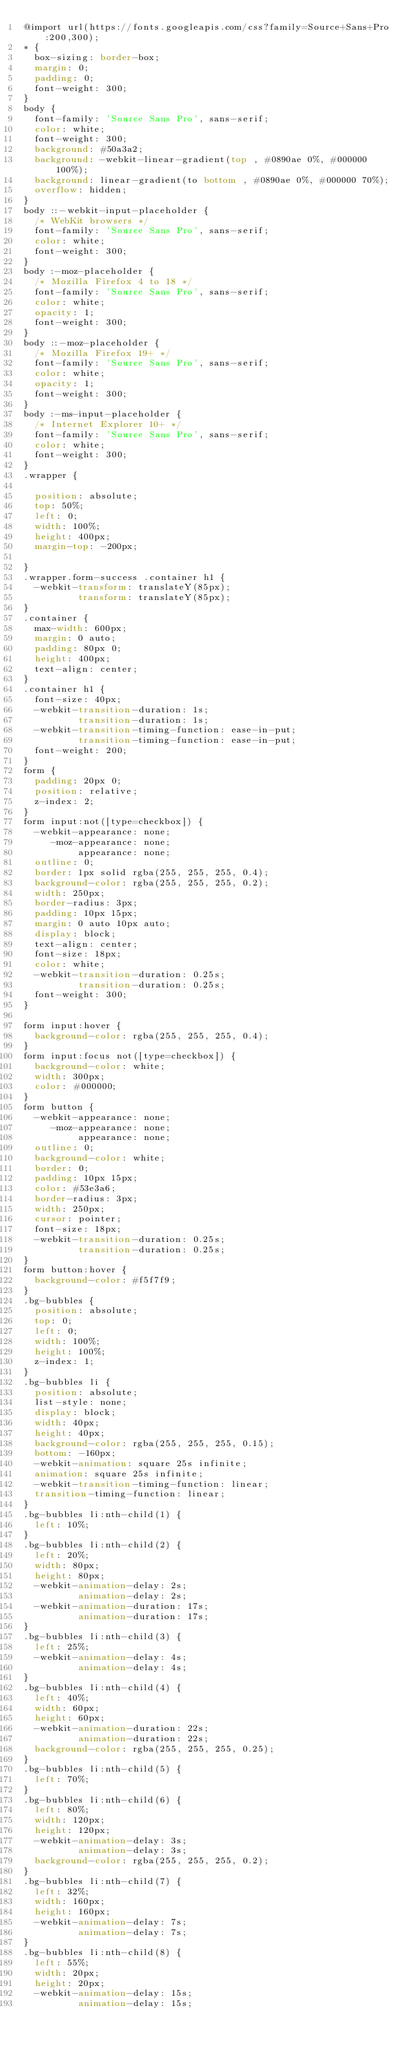<code> <loc_0><loc_0><loc_500><loc_500><_CSS_>@import url(https://fonts.googleapis.com/css?family=Source+Sans+Pro:200,300);
* {
  box-sizing: border-box;
  margin: 0;
  padding: 0;
  font-weight: 300;
}
body {
  font-family: 'Source Sans Pro', sans-serif;
  color: white;
  font-weight: 300;
  background: #50a3a2;
  background: -webkit-linear-gradient(top , #0890ae 0%, #000000 100%);
  background: linear-gradient(to bottom , #0890ae 0%, #000000 70%);
  overflow: hidden;
}
body ::-webkit-input-placeholder {
  /* WebKit browsers */
  font-family: 'Source Sans Pro', sans-serif;
  color: white;
  font-weight: 300;
}
body :-moz-placeholder {
  /* Mozilla Firefox 4 to 18 */
  font-family: 'Source Sans Pro', sans-serif;
  color: white;
  opacity: 1;
  font-weight: 300;
}
body ::-moz-placeholder {
  /* Mozilla Firefox 19+ */
  font-family: 'Source Sans Pro', sans-serif;
  color: white;
  opacity: 1;
  font-weight: 300;
}
body :-ms-input-placeholder {
  /* Internet Explorer 10+ */
  font-family: 'Source Sans Pro', sans-serif;
  color: white;
  font-weight: 300;
}
.wrapper {
  
  position: absolute;
  top: 50%;
  left: 0;
  width: 100%;
  height: 400px;
  margin-top: -200px;
 
}
.wrapper.form-success .container h1 {
  -webkit-transform: translateY(85px);
          transform: translateY(85px);
}
.container {
  max-width: 600px;
  margin: 0 auto;
  padding: 80px 0;
  height: 400px;
  text-align: center;
}
.container h1 {
  font-size: 40px;
  -webkit-transition-duration: 1s;
          transition-duration: 1s;
  -webkit-transition-timing-function: ease-in-put;
          transition-timing-function: ease-in-put;
  font-weight: 200;
}
form {
  padding: 20px 0;
  position: relative;
  z-index: 2;
}
form input:not([type=checkbox]) {
  -webkit-appearance: none;
     -moz-appearance: none;
          appearance: none;
  outline: 0;
  border: 1px solid rgba(255, 255, 255, 0.4);
  background-color: rgba(255, 255, 255, 0.2);
  width: 250px;
  border-radius: 3px;
  padding: 10px 15px;
  margin: 0 auto 10px auto;
  display: block;
  text-align: center;
  font-size: 18px;
  color: white;
  -webkit-transition-duration: 0.25s;
          transition-duration: 0.25s;
  font-weight: 300;
}

form input:hover {
  background-color: rgba(255, 255, 255, 0.4);
}
form input:focus not([type=checkbox]) {
  background-color: white;
  width: 300px;
  color: #000000;
}
form button {
  -webkit-appearance: none;
     -moz-appearance: none;
          appearance: none;
  outline: 0;
  background-color: white;
  border: 0;
  padding: 10px 15px;
  color: #53e3a6;
  border-radius: 3px;
  width: 250px;
  cursor: pointer;
  font-size: 18px;
  -webkit-transition-duration: 0.25s;
          transition-duration: 0.25s;
}
form button:hover {
  background-color: #f5f7f9;
}
.bg-bubbles {
  position: absolute;
  top: 0;
  left: 0;
  width: 100%;
  height: 100%;
  z-index: 1;
}
.bg-bubbles li {
  position: absolute;
  list-style: none;
  display: block;
  width: 40px;
  height: 40px;
  background-color: rgba(255, 255, 255, 0.15);
  bottom: -160px;
  -webkit-animation: square 25s infinite;
  animation: square 25s infinite;
  -webkit-transition-timing-function: linear;
  transition-timing-function: linear;
}
.bg-bubbles li:nth-child(1) {
  left: 10%;
}
.bg-bubbles li:nth-child(2) {
  left: 20%;
  width: 80px;
  height: 80px;
  -webkit-animation-delay: 2s;
          animation-delay: 2s;
  -webkit-animation-duration: 17s;
          animation-duration: 17s;
}
.bg-bubbles li:nth-child(3) {
  left: 25%;
  -webkit-animation-delay: 4s;
          animation-delay: 4s;
}
.bg-bubbles li:nth-child(4) {
  left: 40%;
  width: 60px;
  height: 60px;
  -webkit-animation-duration: 22s;
          animation-duration: 22s;
  background-color: rgba(255, 255, 255, 0.25);
}
.bg-bubbles li:nth-child(5) {
  left: 70%;
}
.bg-bubbles li:nth-child(6) {
  left: 80%;
  width: 120px;
  height: 120px;
  -webkit-animation-delay: 3s;
          animation-delay: 3s;
  background-color: rgba(255, 255, 255, 0.2);
}
.bg-bubbles li:nth-child(7) {
  left: 32%;
  width: 160px;
  height: 160px;
  -webkit-animation-delay: 7s;
          animation-delay: 7s;
}
.bg-bubbles li:nth-child(8) {
  left: 55%;
  width: 20px;
  height: 20px;
  -webkit-animation-delay: 15s;
          animation-delay: 15s;</code> 